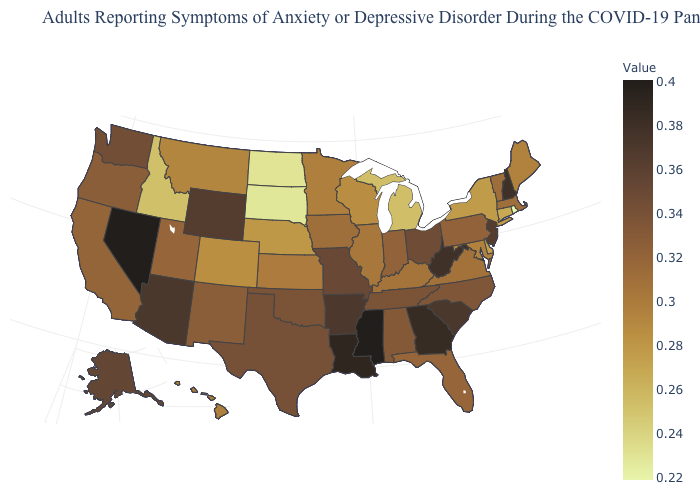Among the states that border Utah , which have the lowest value?
Write a very short answer. Idaho. Does Washington have a lower value than West Virginia?
Concise answer only. Yes. Does New Hampshire have the highest value in the Northeast?
Answer briefly. Yes. 